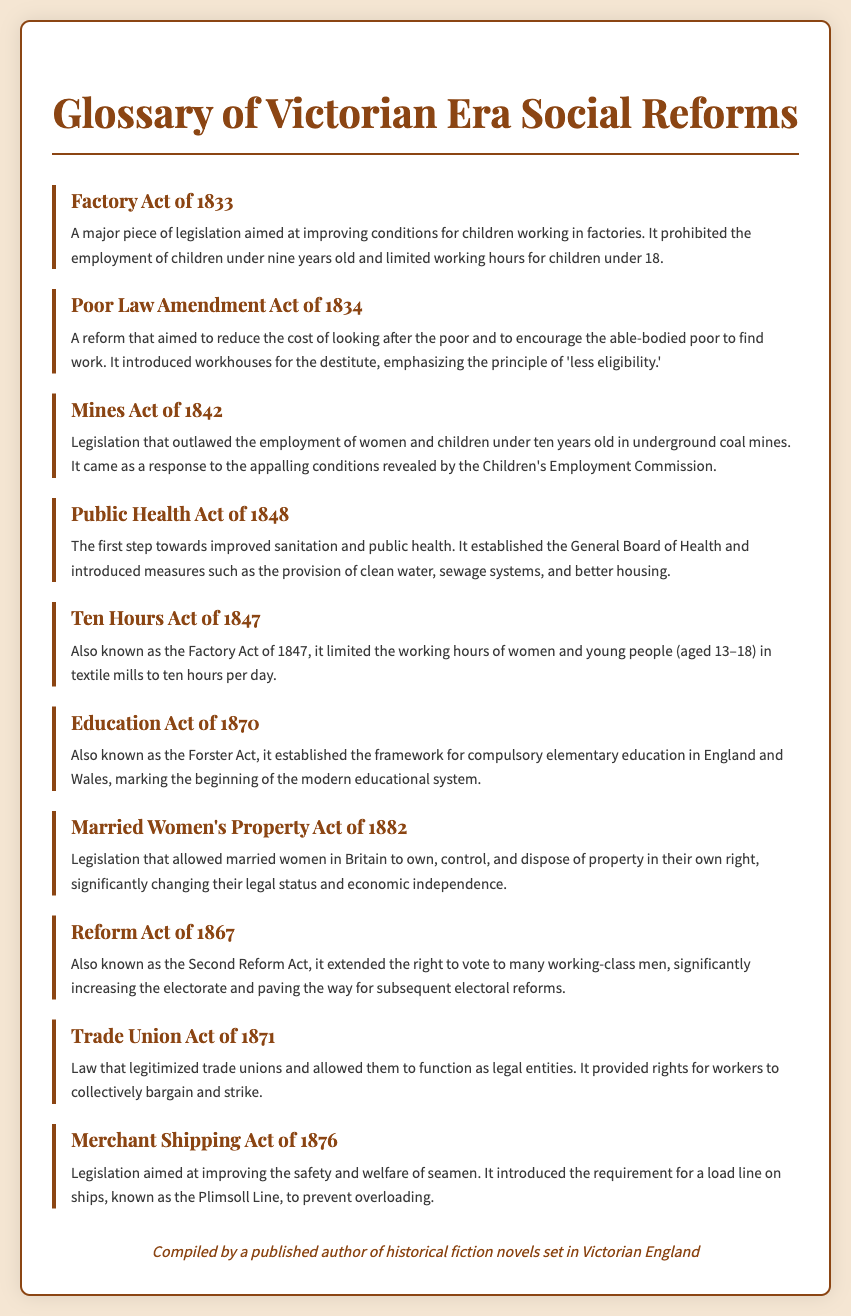What year was the Factory Act passed? The document states that the Factory Act of 1833 was a major piece of legislation aimed at improving conditions for children.
Answer: 1833 What does the Poor Law Amendment Act emphasize? According to the document, the Poor Law Amendment Act emphasized the principle of 'less eligibility.'
Answer: 'less eligibility' What age group was affected by the Mines Act of 1842? The Mines Act of 1842 outlawed the employment of women and children under ten years old in underground coal mines.
Answer: under ten What was established by the Public Health Act of 1848? The document notes that the Public Health Act of 1848 established the General Board of Health.
Answer: General Board of Health What educational framework did the Education Act of 1870 establish? The Education Act of 1870 established the framework for compulsory elementary education in England and Wales.
Answer: compulsory elementary education Which act allowed married women to own property? The document states that the Married Women's Property Act of 1882 allowed married women to own, control, and dispose of property.
Answer: Married Women's Property Act of 1882 How many working-class men gained the right to vote due to the Reform Act of 1867? The Reform Act of 1867 significantly extended the right to vote but the document does not specify an exact number, focusing instead on "many working-class men."
Answer: many What did the Trade Union Act of 1871 provide rights for? The Trade Union Act of 1871 provided rights for workers to collectively bargain and strike.
Answer: collectively bargain and strike What safety measure was introduced by the Merchant Shipping Act of 1876? The document states that the Merchant Shipping Act of 1876 introduced the requirement for a load line on ships.
Answer: load line 